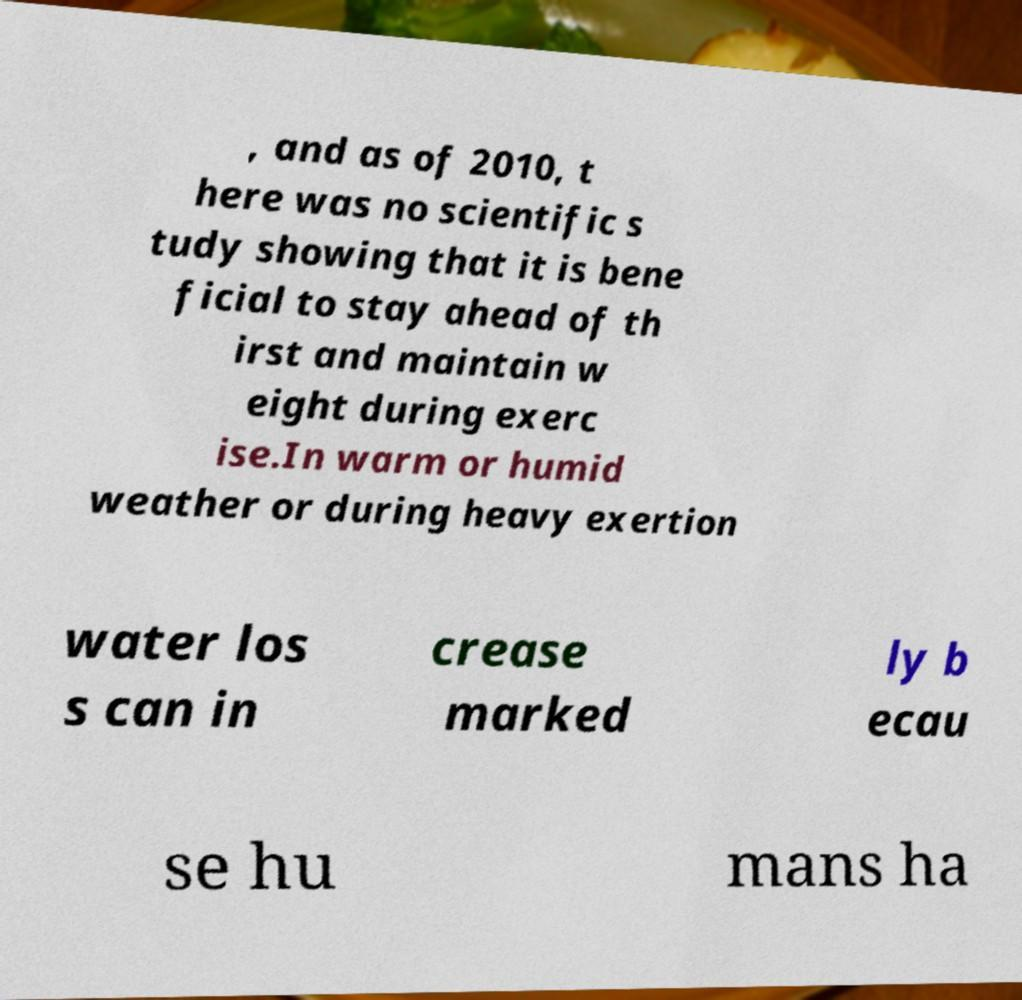I need the written content from this picture converted into text. Can you do that? , and as of 2010, t here was no scientific s tudy showing that it is bene ficial to stay ahead of th irst and maintain w eight during exerc ise.In warm or humid weather or during heavy exertion water los s can in crease marked ly b ecau se hu mans ha 